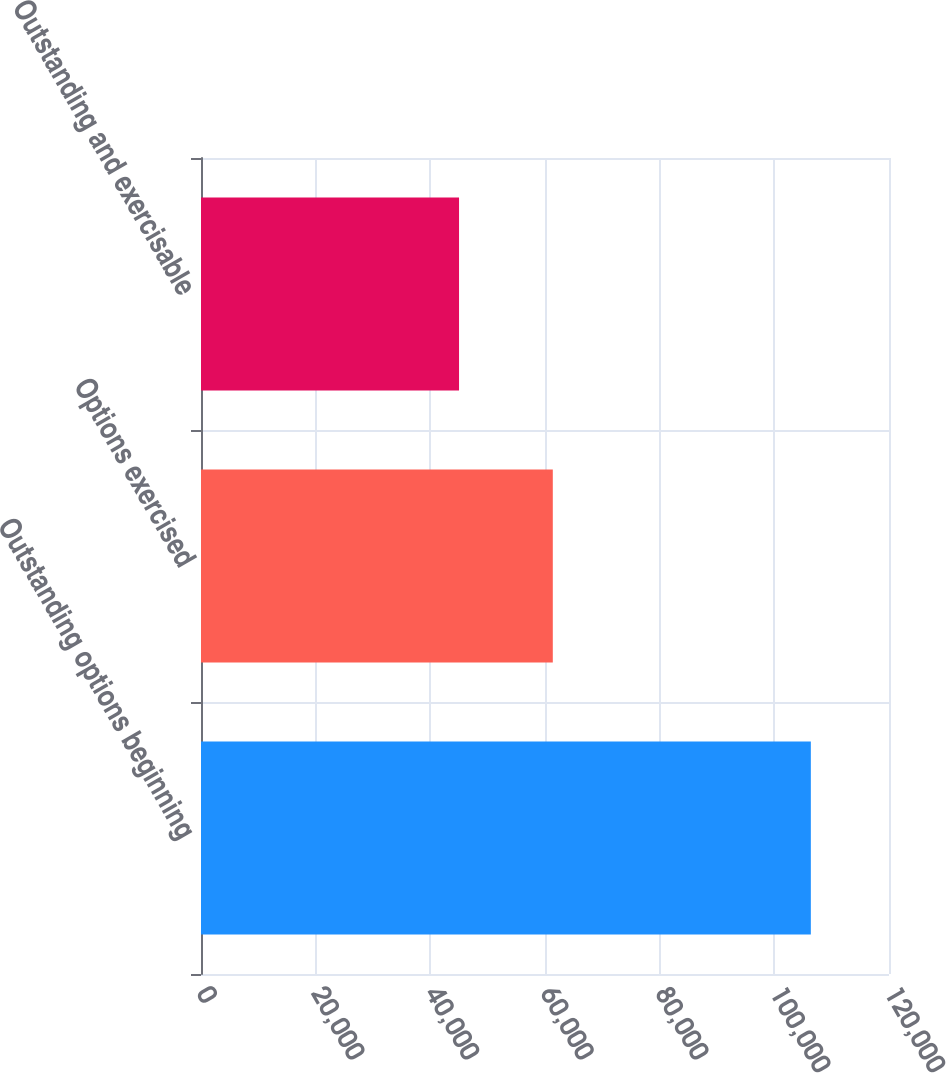<chart> <loc_0><loc_0><loc_500><loc_500><bar_chart><fcel>Outstanding options beginning<fcel>Options exercised<fcel>Outstanding and exercisable<nl><fcel>106368<fcel>61361<fcel>45007<nl></chart> 